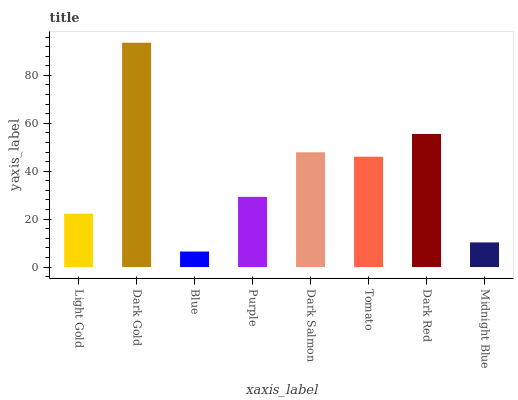Is Blue the minimum?
Answer yes or no. Yes. Is Dark Gold the maximum?
Answer yes or no. Yes. Is Dark Gold the minimum?
Answer yes or no. No. Is Blue the maximum?
Answer yes or no. No. Is Dark Gold greater than Blue?
Answer yes or no. Yes. Is Blue less than Dark Gold?
Answer yes or no. Yes. Is Blue greater than Dark Gold?
Answer yes or no. No. Is Dark Gold less than Blue?
Answer yes or no. No. Is Tomato the high median?
Answer yes or no. Yes. Is Purple the low median?
Answer yes or no. Yes. Is Dark Gold the high median?
Answer yes or no. No. Is Midnight Blue the low median?
Answer yes or no. No. 